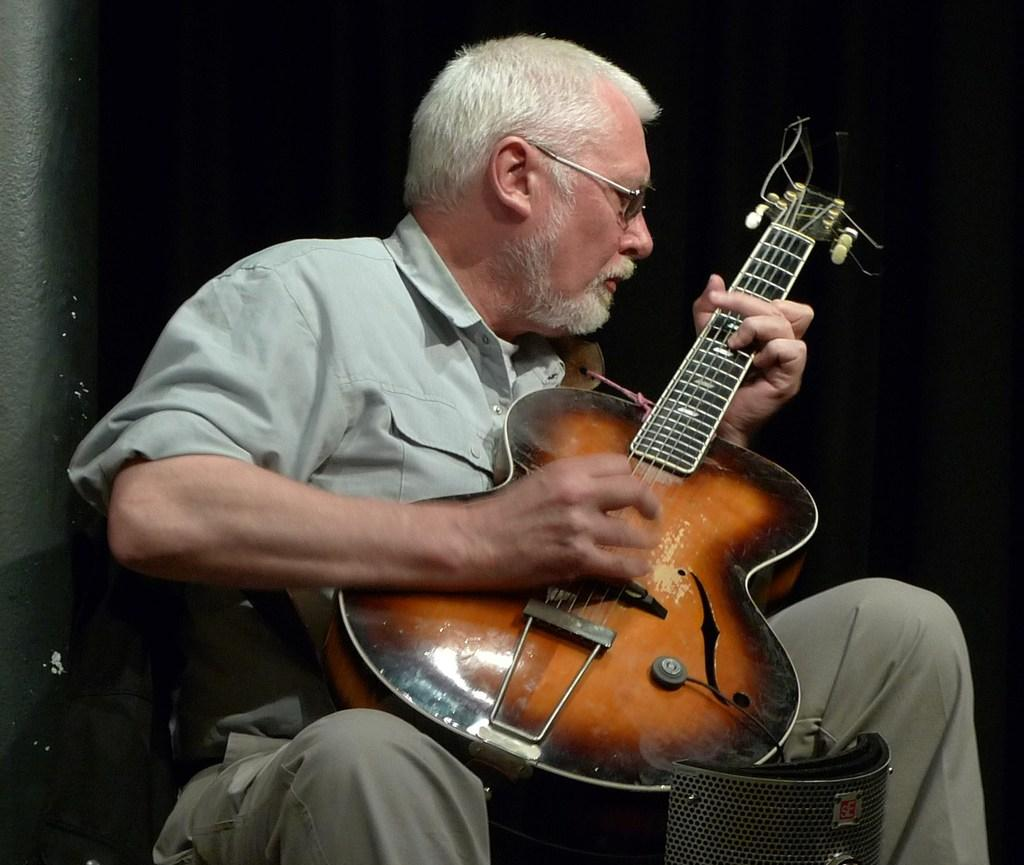What is the main subject of the image? The main subject of the image is a man. What is the man doing in the image? The man is sitting and playing a guitar. Where is the doll located in the image? There is no doll present in the image. What type of house can be seen in the background of the image? There is no house visible in the image; it only features a man sitting and playing a guitar. 